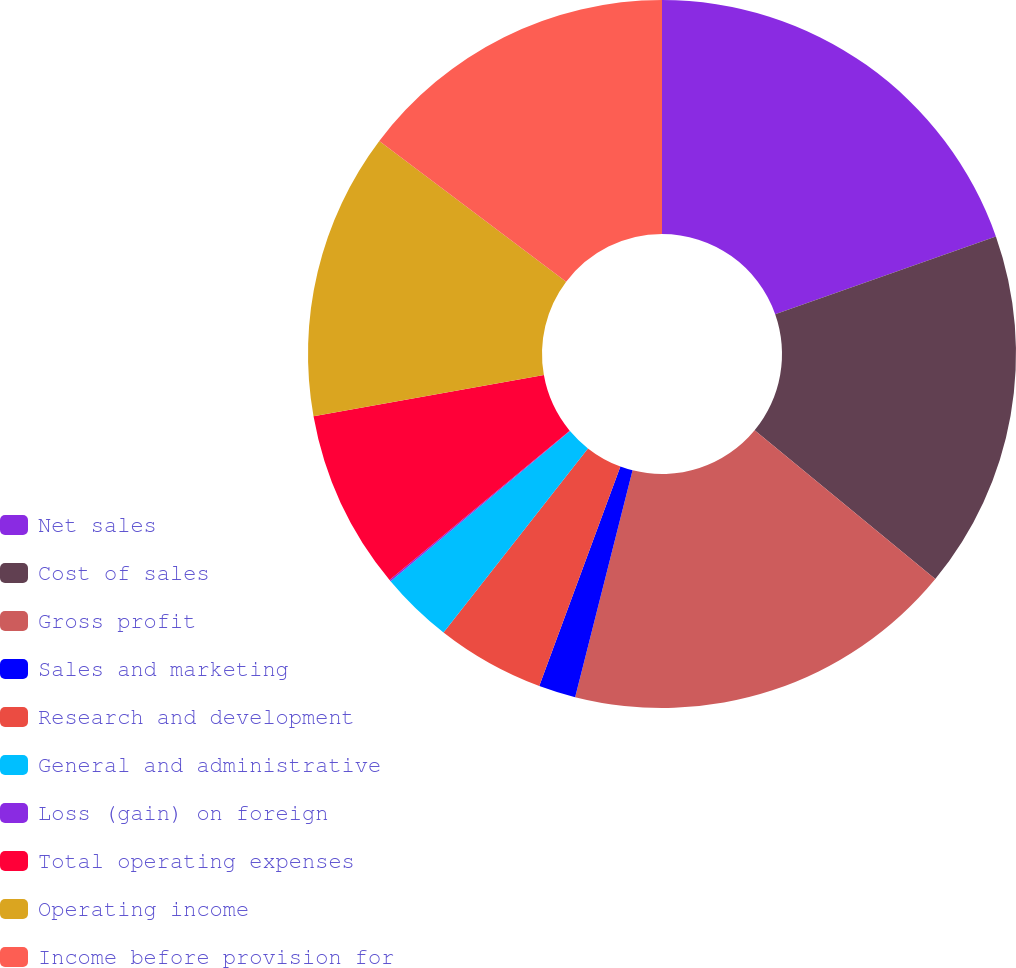<chart> <loc_0><loc_0><loc_500><loc_500><pie_chart><fcel>Net sales<fcel>Cost of sales<fcel>Gross profit<fcel>Sales and marketing<fcel>Research and development<fcel>General and administrative<fcel>Loss (gain) on foreign<fcel>Total operating expenses<fcel>Operating income<fcel>Income before provision for<nl><fcel>19.61%<fcel>16.35%<fcel>17.98%<fcel>1.69%<fcel>4.95%<fcel>3.32%<fcel>0.07%<fcel>8.21%<fcel>13.09%<fcel>14.72%<nl></chart> 